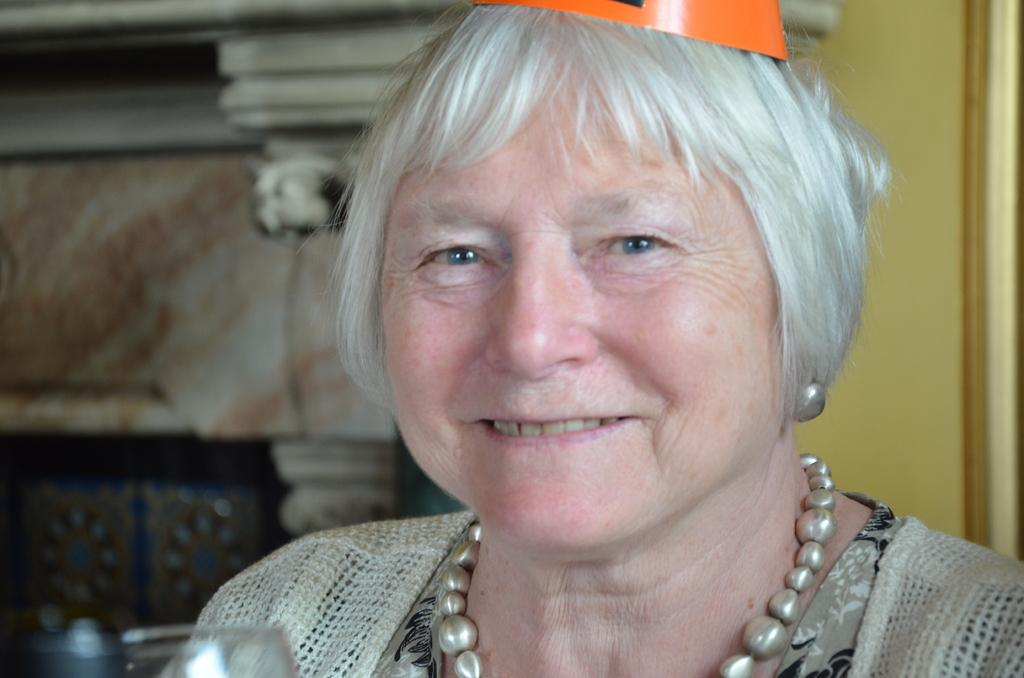Who is present in the image? There is a woman in the image. What is the woman wearing on her head? The woman is wearing a cap on her head. What is the woman's facial expression? The woman is smiling. What type of accessory is the woman wearing? The woman is wearing an ornament. Can you see any plastic cacti in the image? There is no mention of plastic cacti in the image, so we cannot confirm their presence. 